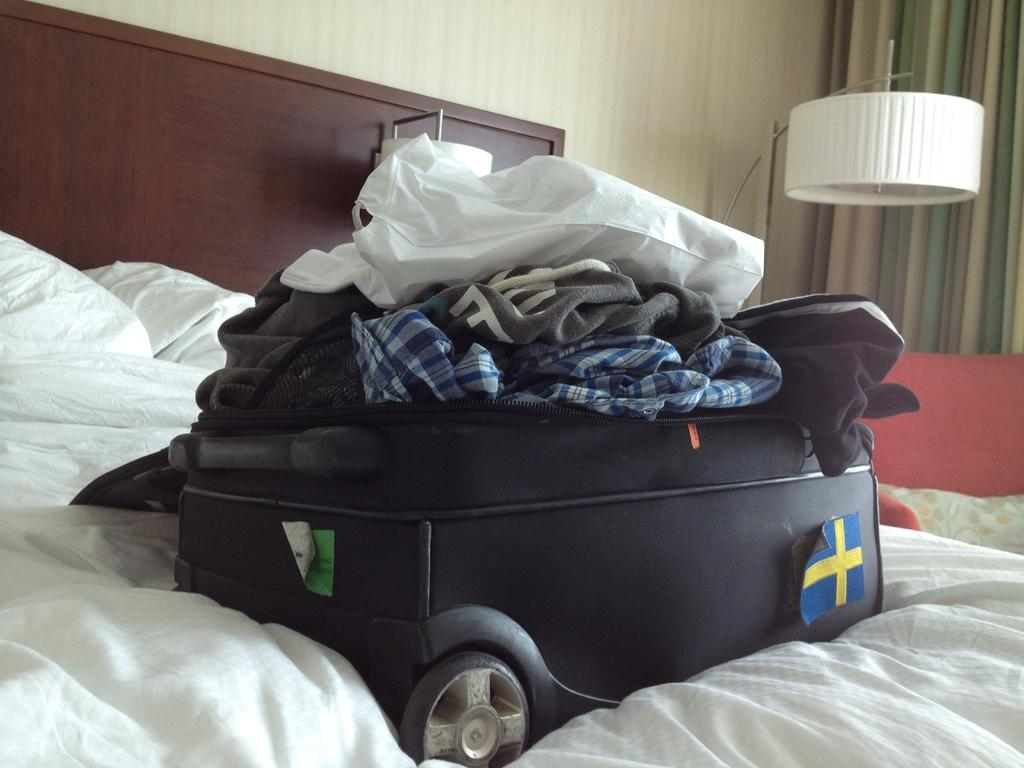What piece of furniture is the main subject in the image? There is a bed in the image. What is placed on the bed? There is a bag on the bed. What is inside the bag? The bag contains clothes. What other piece of furniture is near the bed? There is a chair near the bed. What object provides light in the image? There is a lamp in the image. What type of drink is being poured from the lamp in the image? There is no drink being poured from the lamp in the image; it is a lamp providing light. 